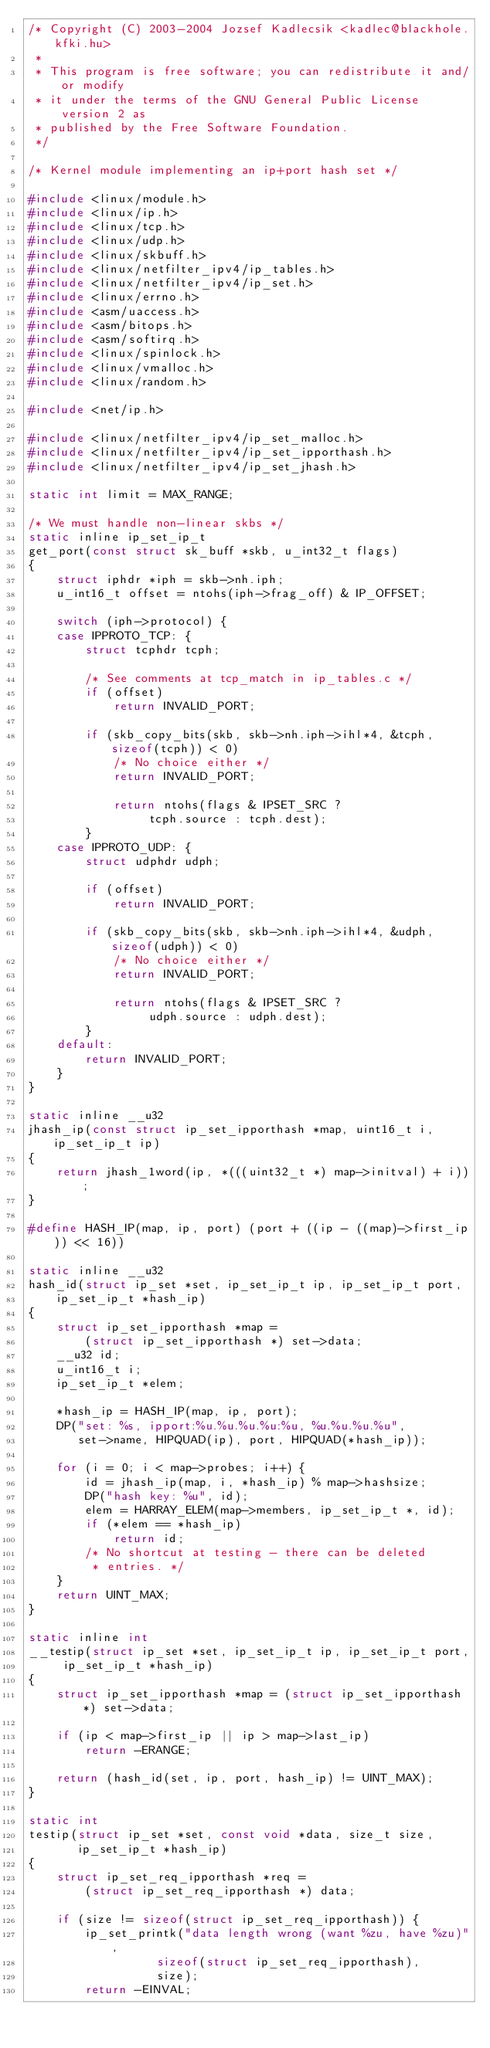Convert code to text. <code><loc_0><loc_0><loc_500><loc_500><_C_>/* Copyright (C) 2003-2004 Jozsef Kadlecsik <kadlec@blackhole.kfki.hu>
 *
 * This program is free software; you can redistribute it and/or modify
 * it under the terms of the GNU General Public License version 2 as
 * published by the Free Software Foundation.  
 */

/* Kernel module implementing an ip+port hash set */

#include <linux/module.h>
#include <linux/ip.h>
#include <linux/tcp.h>
#include <linux/udp.h>
#include <linux/skbuff.h>
#include <linux/netfilter_ipv4/ip_tables.h>
#include <linux/netfilter_ipv4/ip_set.h>
#include <linux/errno.h>
#include <asm/uaccess.h>
#include <asm/bitops.h>
#include <asm/softirq.h>
#include <linux/spinlock.h>
#include <linux/vmalloc.h>
#include <linux/random.h>

#include <net/ip.h>

#include <linux/netfilter_ipv4/ip_set_malloc.h>
#include <linux/netfilter_ipv4/ip_set_ipporthash.h>
#include <linux/netfilter_ipv4/ip_set_jhash.h>

static int limit = MAX_RANGE;

/* We must handle non-linear skbs */
static inline ip_set_ip_t
get_port(const struct sk_buff *skb, u_int32_t flags)
{
	struct iphdr *iph = skb->nh.iph;
	u_int16_t offset = ntohs(iph->frag_off) & IP_OFFSET;

	switch (iph->protocol) {
	case IPPROTO_TCP: {
		struct tcphdr tcph;
		
		/* See comments at tcp_match in ip_tables.c */
		if (offset)
			return INVALID_PORT;

		if (skb_copy_bits(skb, skb->nh.iph->ihl*4, &tcph, sizeof(tcph)) < 0)
			/* No choice either */
			return INVALID_PORT;
	     	
	     	return ntohs(flags & IPSET_SRC ?
			     tcph.source : tcph.dest);
	    }
	case IPPROTO_UDP: {
		struct udphdr udph;

		if (offset)
			return INVALID_PORT;

		if (skb_copy_bits(skb, skb->nh.iph->ihl*4, &udph, sizeof(udph)) < 0)
			/* No choice either */
			return INVALID_PORT;
	     	
	     	return ntohs(flags & IPSET_SRC ?
			     udph.source : udph.dest);
	    }
	default:
		return INVALID_PORT;
	}
}

static inline __u32
jhash_ip(const struct ip_set_ipporthash *map, uint16_t i, ip_set_ip_t ip)
{
	return jhash_1word(ip, *(((uint32_t *) map->initval) + i));
}

#define HASH_IP(map, ip, port) (port + ((ip - ((map)->first_ip)) << 16))

static inline __u32
hash_id(struct ip_set *set, ip_set_ip_t ip, ip_set_ip_t port,
	ip_set_ip_t *hash_ip)
{
	struct ip_set_ipporthash *map = 
		(struct ip_set_ipporthash *) set->data;
	__u32 id;
	u_int16_t i;
	ip_set_ip_t *elem;

	*hash_ip = HASH_IP(map, ip, port);
	DP("set: %s, ipport:%u.%u.%u.%u:%u, %u.%u.%u.%u",
	   set->name, HIPQUAD(ip), port, HIPQUAD(*hash_ip));
	
	for (i = 0; i < map->probes; i++) {
		id = jhash_ip(map, i, *hash_ip) % map->hashsize;
		DP("hash key: %u", id);
		elem = HARRAY_ELEM(map->members, ip_set_ip_t *, id);
		if (*elem == *hash_ip)
			return id;
		/* No shortcut at testing - there can be deleted
		 * entries. */
	}
	return UINT_MAX;
}

static inline int
__testip(struct ip_set *set, ip_set_ip_t ip, ip_set_ip_t port,
	 ip_set_ip_t *hash_ip)
{
	struct ip_set_ipporthash *map = (struct ip_set_ipporthash *) set->data;
	
	if (ip < map->first_ip || ip > map->last_ip)
		return -ERANGE;

	return (hash_id(set, ip, port, hash_ip) != UINT_MAX);
}

static int
testip(struct ip_set *set, const void *data, size_t size,
       ip_set_ip_t *hash_ip)
{
	struct ip_set_req_ipporthash *req = 
	    (struct ip_set_req_ipporthash *) data;

	if (size != sizeof(struct ip_set_req_ipporthash)) {
		ip_set_printk("data length wrong (want %zu, have %zu)",
			      sizeof(struct ip_set_req_ipporthash),
			      size);
		return -EINVAL;</code> 